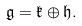Convert formula to latex. <formula><loc_0><loc_0><loc_500><loc_500>\mathfrak { g } = \mathfrak { k } \oplus \mathfrak { h } .</formula> 